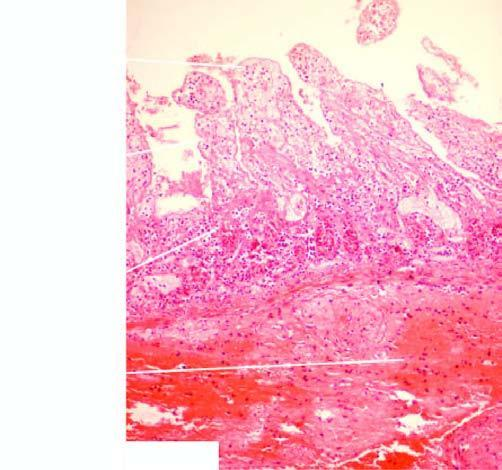what shows coagulative necrosis and submucosal haemorrhages?
Answer the question using a single word or phrase. Mucosa in the infarcted area 